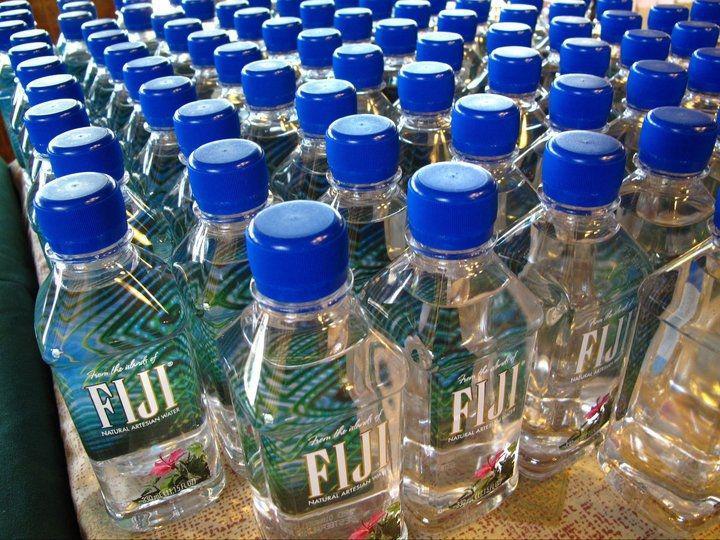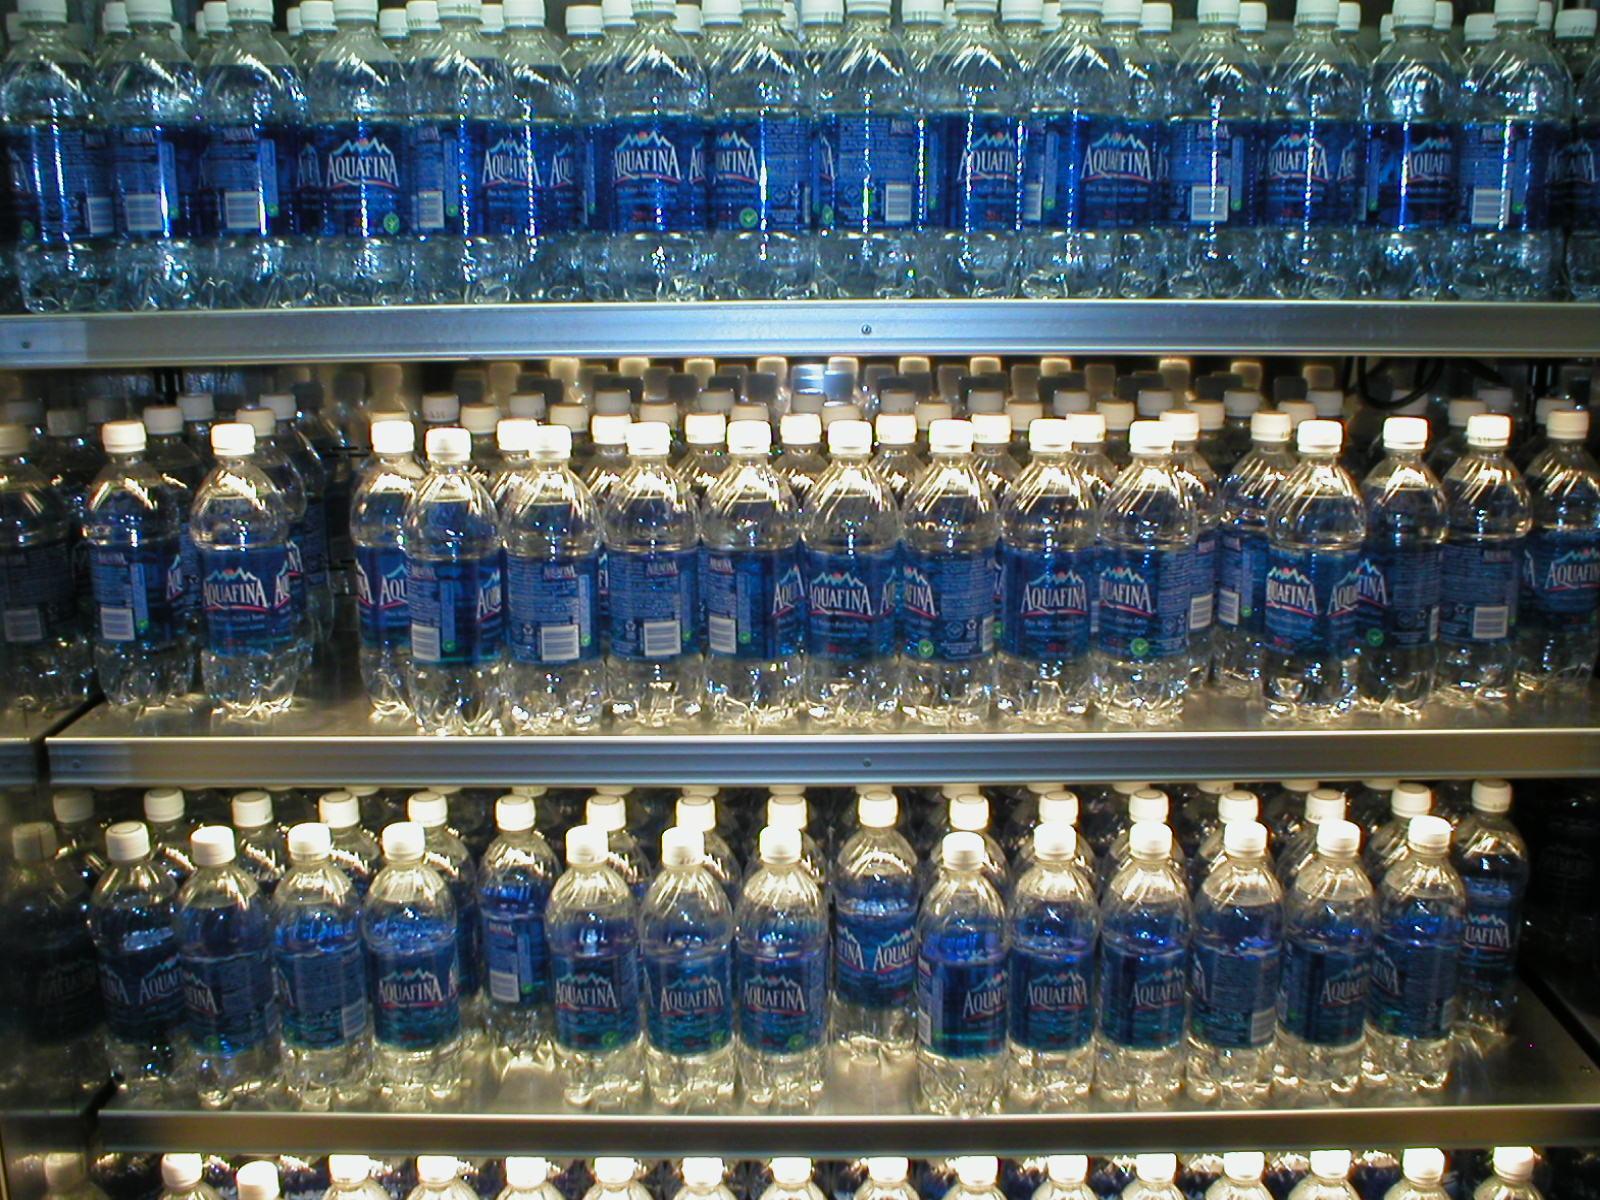The first image is the image on the left, the second image is the image on the right. Evaluate the accuracy of this statement regarding the images: "many plastic bottles are in large piles". Is it true? Answer yes or no. No. The first image is the image on the left, the second image is the image on the right. Evaluate the accuracy of this statement regarding the images: "In the image on the right the water bottles are stacked on shelves.". Is it true? Answer yes or no. Yes. 